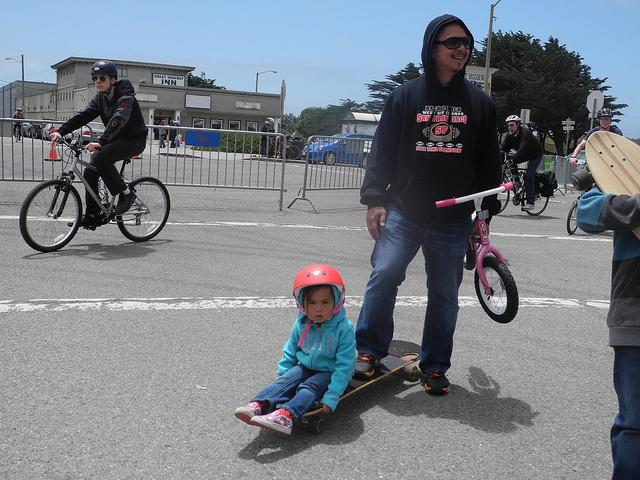Why is the child on the skateboard wearing a helmet? safety 